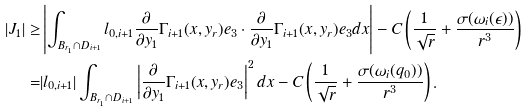Convert formula to latex. <formula><loc_0><loc_0><loc_500><loc_500>| J _ { 1 } | \geq & \left | \int _ { B _ { r _ { 1 } } \cap D _ { i + 1 } } l _ { 0 , i + 1 } \frac { \partial } { \partial y _ { 1 } } \Gamma _ { i + 1 } ( x , y _ { r } ) e _ { 3 } \cdot \frac { \partial } { \partial y _ { 1 } } \Gamma _ { i + 1 } ( x , y _ { r } ) e _ { 3 } d x \right | - C \left ( \frac { 1 } { \sqrt { r } } + \frac { \sigma ( \omega _ { i } ( \epsilon ) ) } { r ^ { 3 } } \right ) \\ = & | l _ { 0 , i + 1 } | \int _ { B _ { r _ { 1 } } \cap D _ { i + 1 } } \left | \frac { \partial } { \partial y _ { 1 } } \Gamma _ { i + 1 } ( x , y _ { r } ) e _ { 3 } \right | ^ { 2 } d x - C \left ( \frac { 1 } { \sqrt { r } } + \frac { \sigma ( \omega _ { i } ( q _ { 0 } ) ) } { r ^ { 3 } } \right ) .</formula> 